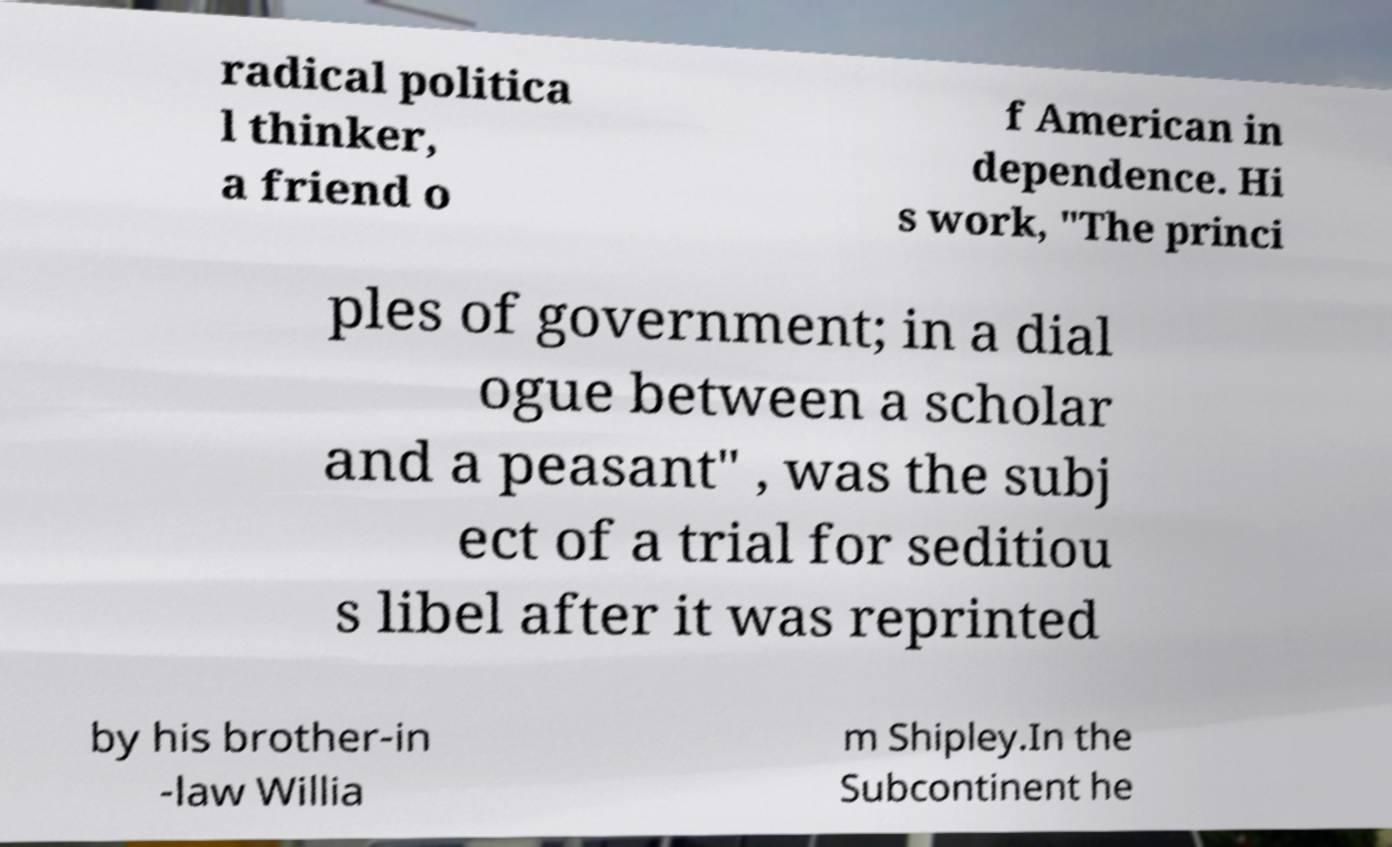Can you read and provide the text displayed in the image?This photo seems to have some interesting text. Can you extract and type it out for me? radical politica l thinker, a friend o f American in dependence. Hi s work, "The princi ples of government; in a dial ogue between a scholar and a peasant" , was the subj ect of a trial for seditiou s libel after it was reprinted by his brother-in -law Willia m Shipley.In the Subcontinent he 